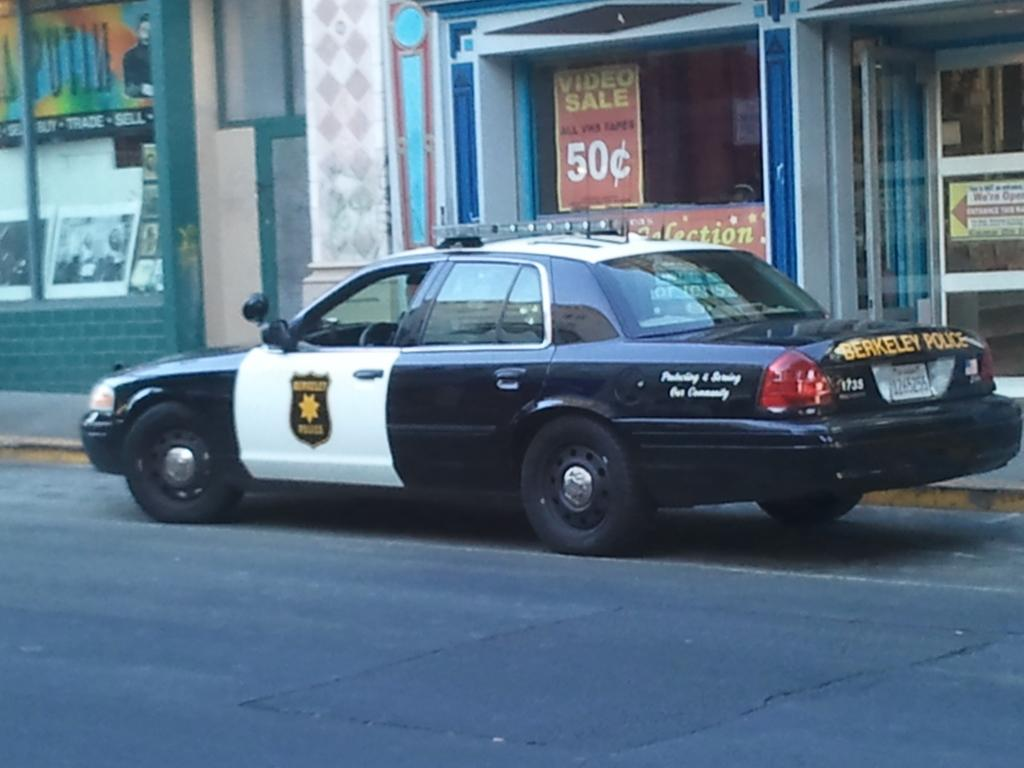<image>
Provide a brief description of the given image. a cop car with the name Berkeley on it 